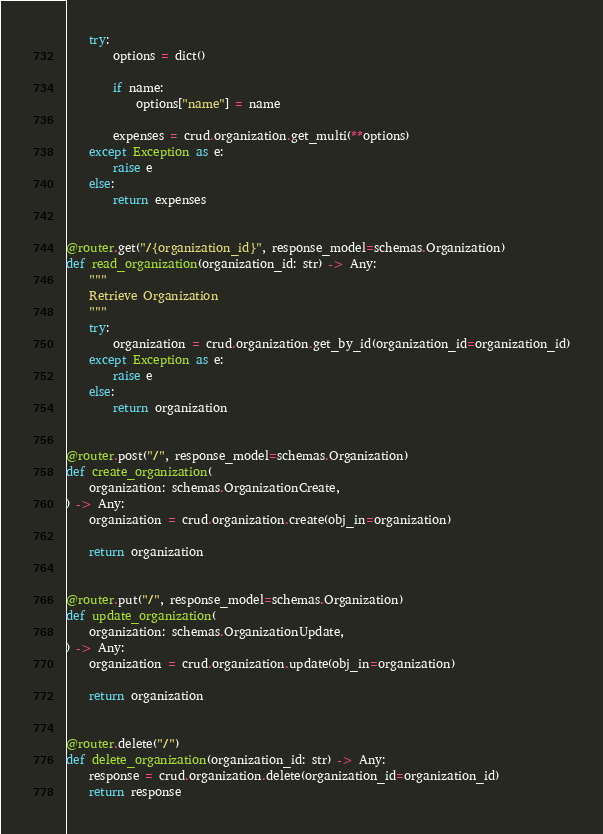<code> <loc_0><loc_0><loc_500><loc_500><_Python_>    try:
        options = dict()

        if name:
            options["name"] = name

        expenses = crud.organization.get_multi(**options)
    except Exception as e:
        raise e
    else:
        return expenses


@router.get("/{organization_id}", response_model=schemas.Organization)
def read_organization(organization_id: str) -> Any:
    """
    Retrieve Organization
    """
    try:
        organization = crud.organization.get_by_id(organization_id=organization_id)
    except Exception as e:
        raise e
    else:
        return organization


@router.post("/", response_model=schemas.Organization)
def create_organization(
    organization: schemas.OrganizationCreate,
) -> Any:
    organization = crud.organization.create(obj_in=organization)

    return organization


@router.put("/", response_model=schemas.Organization)
def update_organization(
    organization: schemas.OrganizationUpdate,
) -> Any:
    organization = crud.organization.update(obj_in=organization)

    return organization


@router.delete("/")
def delete_organization(organization_id: str) -> Any:
    response = crud.organization.delete(organization_id=organization_id)
    return response</code> 